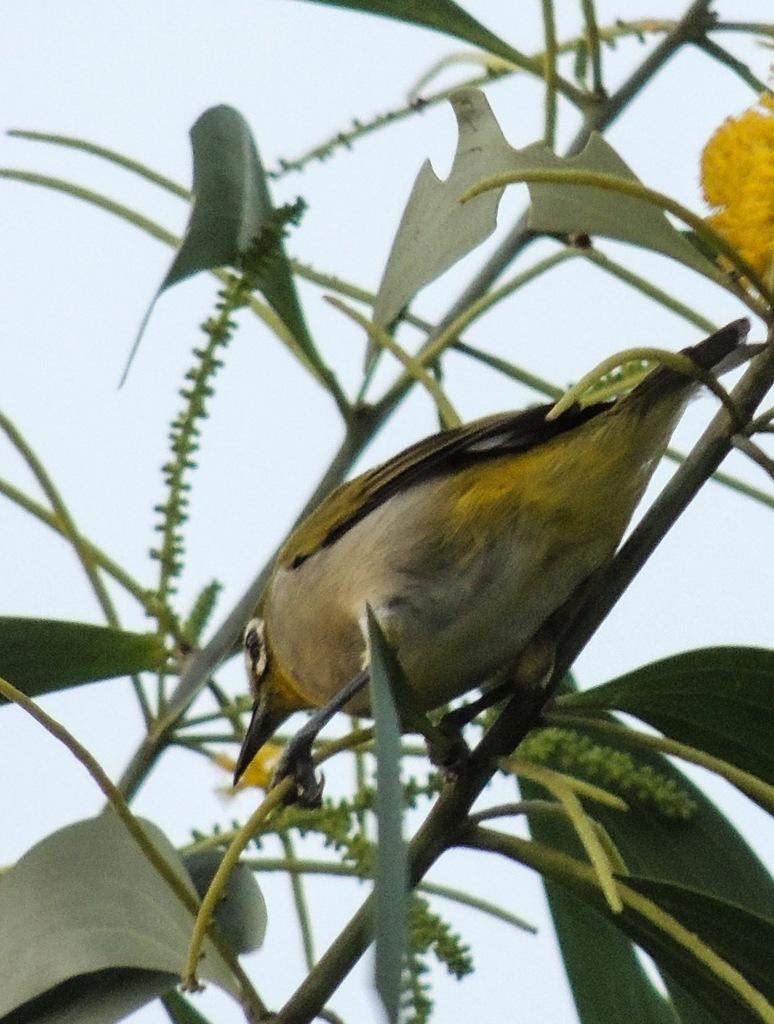What is present in the image? There is a plant in the image. What can be observed about the plant? The plant has leaves. Is there any other living creature in the image? Yes, there is a bird sitting on the stem of the plant. What can be seen in the background of the image? The sky is visible in the background of the image. What type of stove can be seen in the image? There is no stove present in the image. Can you tell me how many people are reading in the image? There are no people reading in the image; it features a plant with a bird on its stem and a visible sky in the background. 